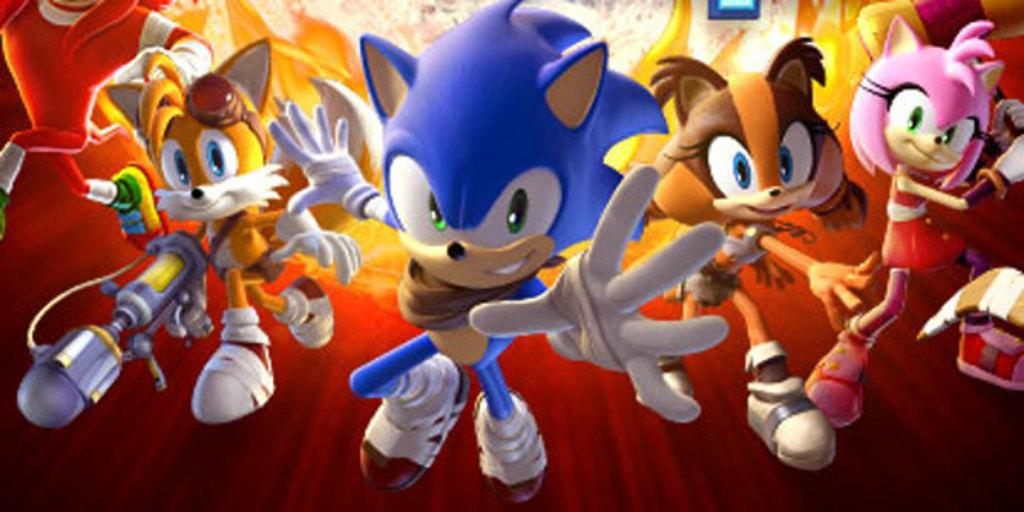What type of picture is the image? The image is an animated picture. What kind of characters can be seen in the image? There are cartoon characters in the image. Can you see a tiger grazing on the grass in the image? There is no tiger or grass present in the image; it features animated cartoon characters. 